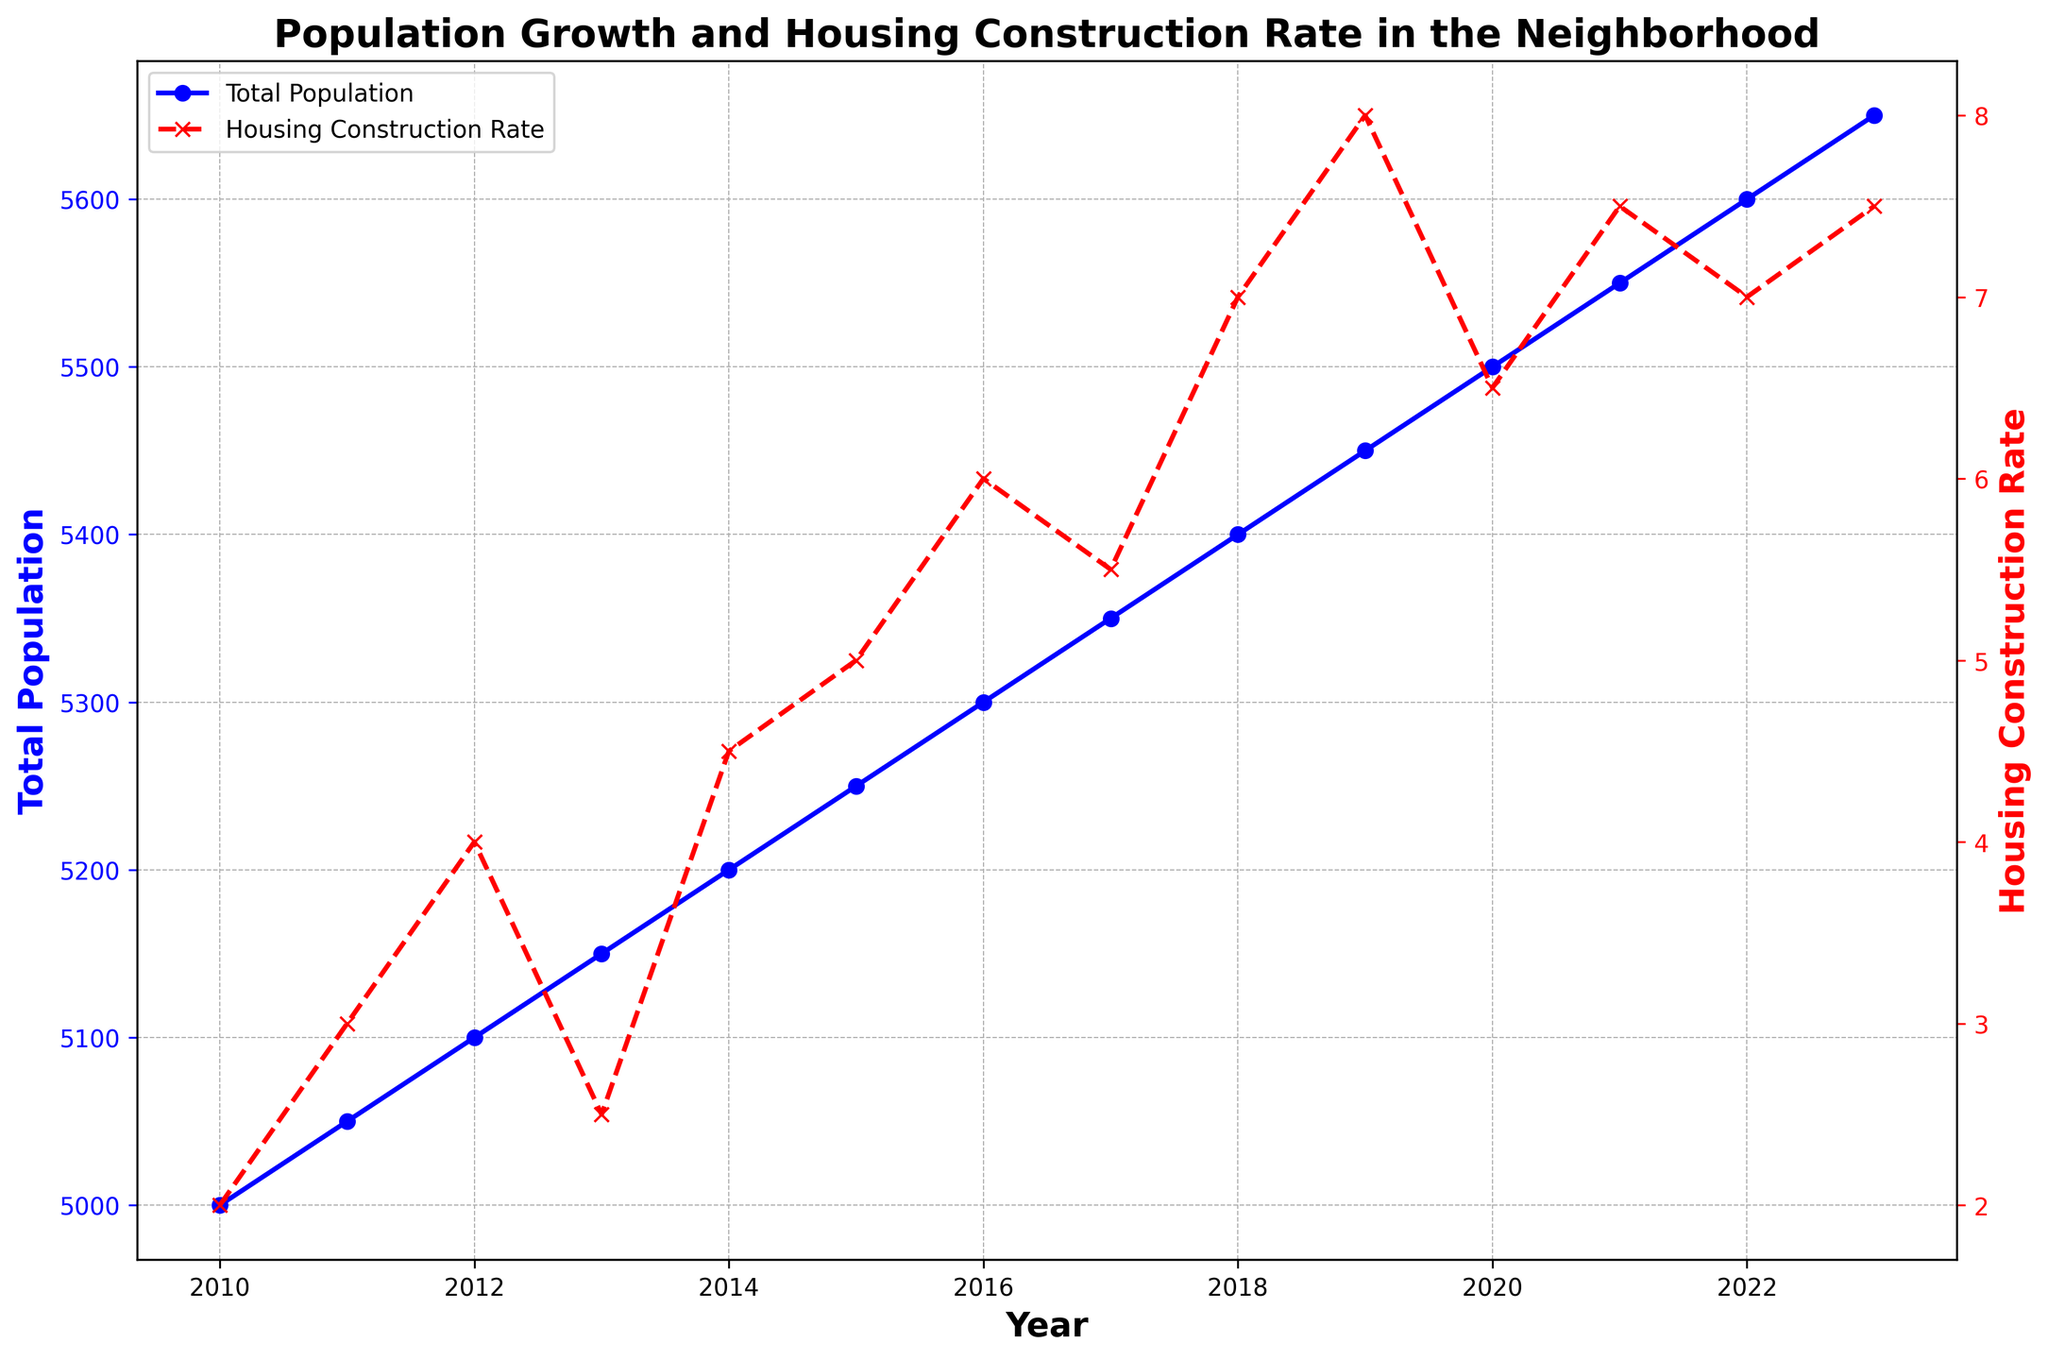What was the Total Population in 2015? To find the Total Population in 2015, locate the data point for the year 2015 on the x-axis and note the corresponding y-axis value for Total Population.
Answer: 5250 How did the Housing Construction Rate change between 2019 and 2020? Locate the data points for the years 2019 and 2020. Note the corresponding values for the Housing Construction Rate and subtract the 2019 value from the 2020 value: 6.5 - 8 = -1.5.
Answer: Decreased by 1.5 Which year had the highest Housing Construction Rate? Identify the year where the red line (Housing Construction Rate) reaches its highest point.
Answer: 2019 Compare the Total Population growth and Housing Construction Rate between 2012 and 2013. Note the Total Population and Housing Construction Rate for both years. Total Population grew from 5100 to 5150 (an increase of 50), and Housing Construction Rate decreased from 4 to 2.5 (a decrease of 1.5).
Answer: Total Population increased, Housing Construction Rate decreased What was the average Housing Construction Rate from 2018 to 2020? Add the Housing Construction Rates for 2018, 2019, and 2020 (7 + 8 + 6.5) and then divide by 3 to find the average: (7 + 8 + 6.5) / 3 = 7.17.
Answer: 7.17 Between 2013 and 2014, did the Total Population increase or decrease, and by how much? Check the Total Population values for 2013 and 2014. Total Population increased from 5150 to 5200. Subtract the earlier value from the later value: 5200 - 5150 = 50.
Answer: Increased by 50 During which year(s) did both the Total Population and Housing Construction Rate increase? Compare the Total Population and Housing Construction Rate year over year. Both metrics increased in years 2011, 2012, 2014, 2015, 2016, 2018, 2021, and 2022.
Answer: 2011, 2012, 2014, 2015, 2016, 2018, 2021, 2022 What is the trend in Total Population from 2010 to 2023? Observe the direction of the blue line (Total Population) from 2010 to 2023. It consistently increases.
Answer: Increasing In which year did the Total Population reach 5500? Locate the point where the blue line reaches 5500 on the y-axis and note the corresponding year on the x-axis.
Answer: 2020 How much did the Housing Construction Rate increase from 2016 to 2017? Find the Housing Construction Rates for 2016 and 2017. Subtract 2016's rate from 2017's rate: 5.5 - 6 = -0.5.
Answer: Decreased by 0.5 